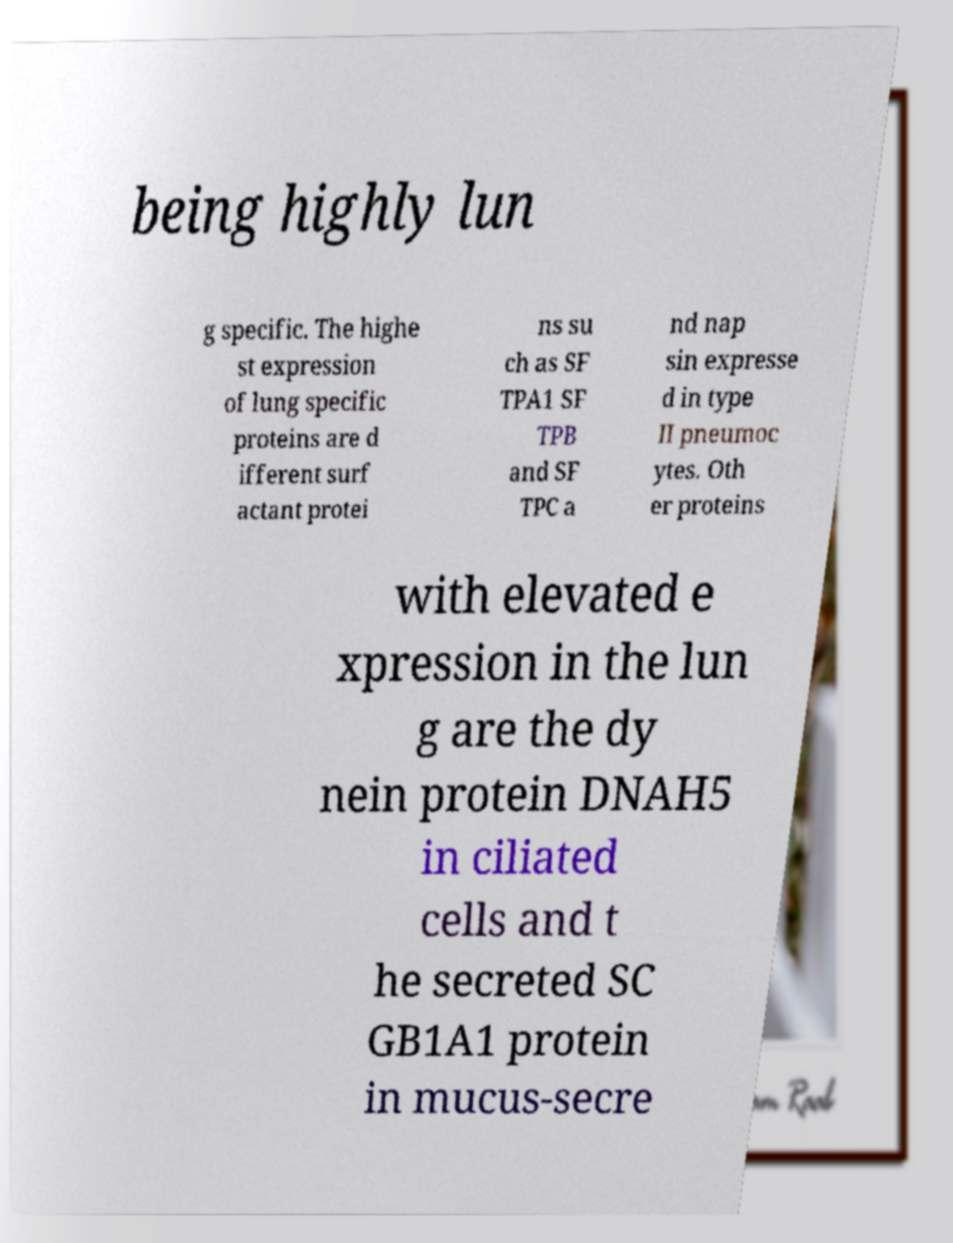Can you accurately transcribe the text from the provided image for me? being highly lun g specific. The highe st expression of lung specific proteins are d ifferent surf actant protei ns su ch as SF TPA1 SF TPB and SF TPC a nd nap sin expresse d in type II pneumoc ytes. Oth er proteins with elevated e xpression in the lun g are the dy nein protein DNAH5 in ciliated cells and t he secreted SC GB1A1 protein in mucus-secre 